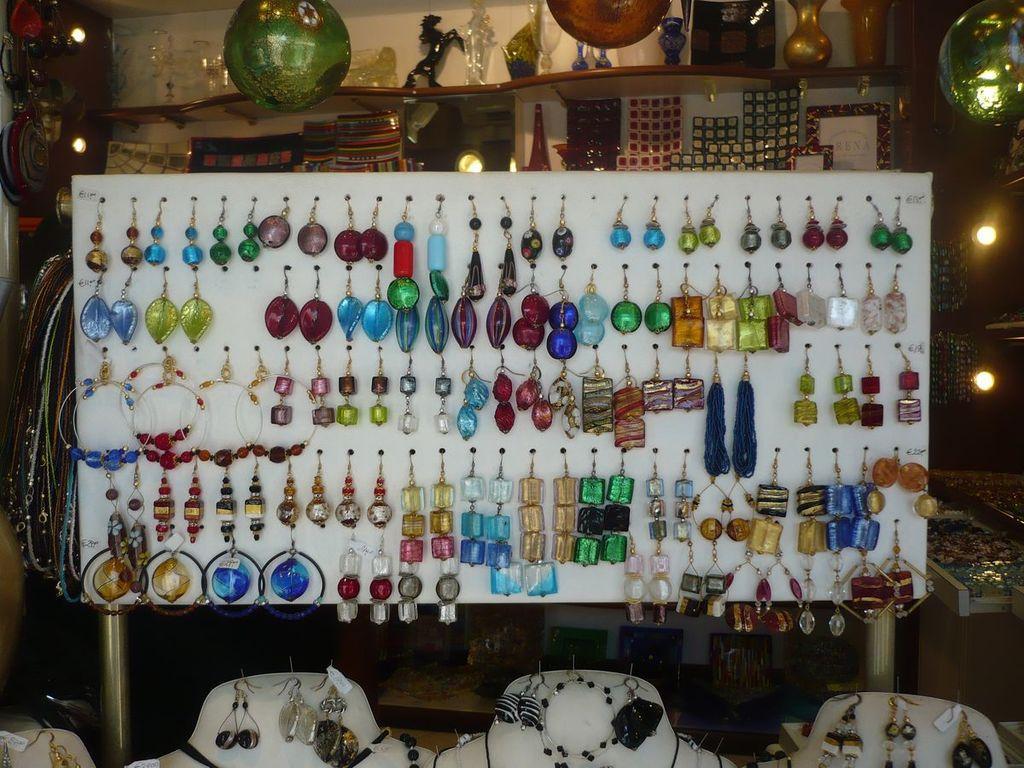Can you describe this image briefly? In this picture we can observe different types of earrings hanged to the white color board. In the background there is a shelf. We can observe green color spheres in this picture. We can observe yellow color lights in the background. 